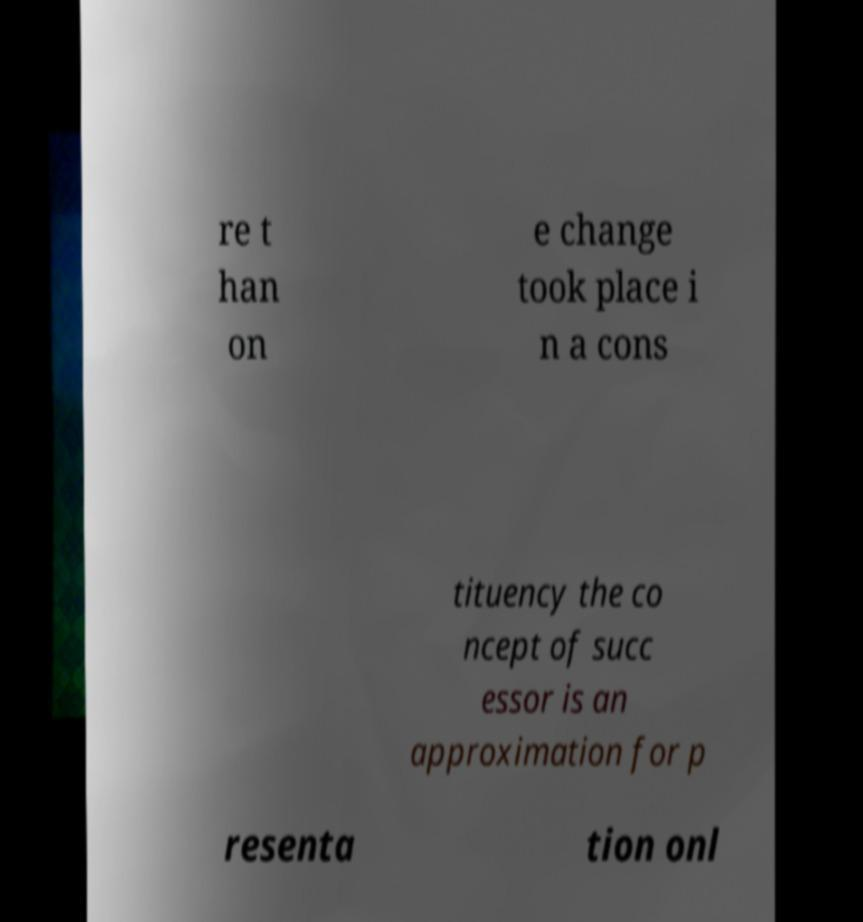Could you extract and type out the text from this image? re t han on e change took place i n a cons tituency the co ncept of succ essor is an approximation for p resenta tion onl 